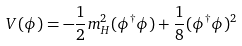Convert formula to latex. <formula><loc_0><loc_0><loc_500><loc_500>V ( \phi ) = - \frac { 1 } { 2 } m ^ { 2 } _ { H } ( \phi ^ { \dagger } \phi ) + \frac { 1 } { 8 } ( \phi ^ { \dagger } \phi ) ^ { 2 }</formula> 